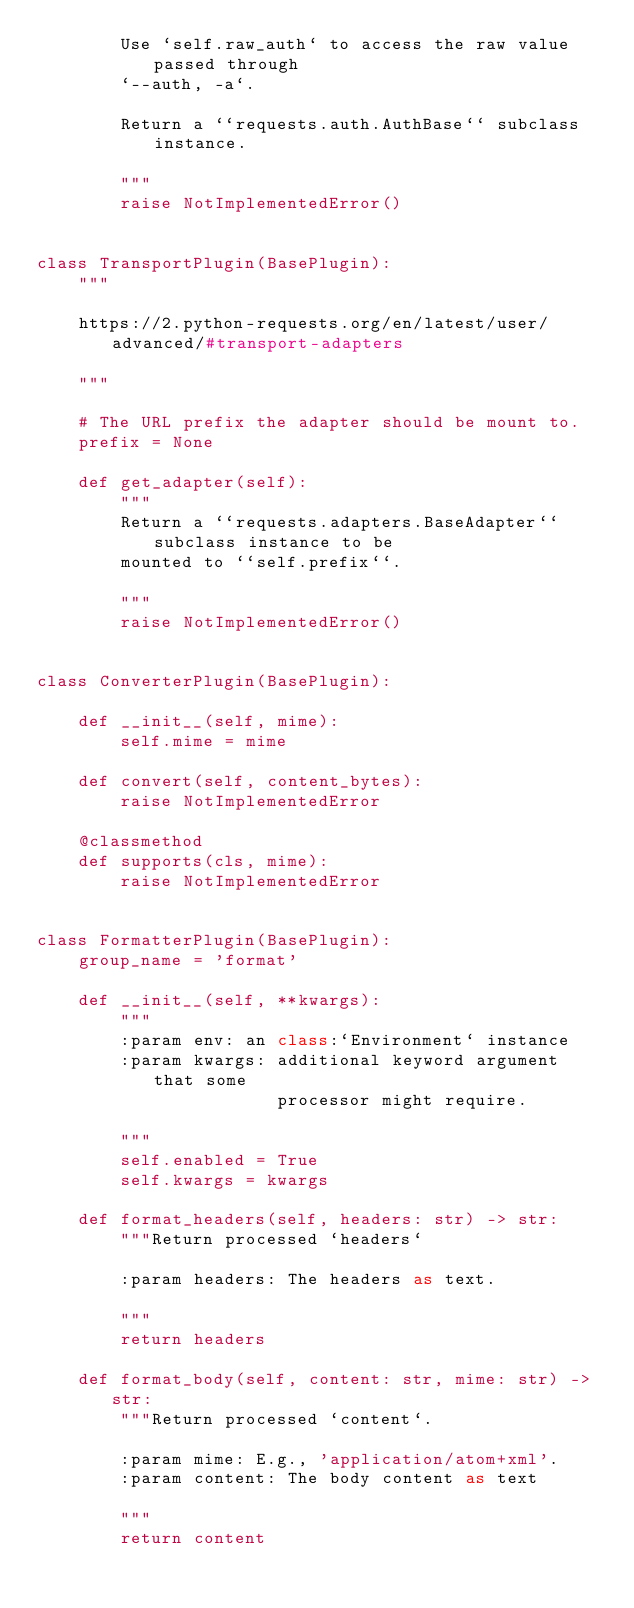<code> <loc_0><loc_0><loc_500><loc_500><_Python_>        Use `self.raw_auth` to access the raw value passed through
        `--auth, -a`.

        Return a ``requests.auth.AuthBase`` subclass instance.

        """
        raise NotImplementedError()


class TransportPlugin(BasePlugin):
    """

    https://2.python-requests.org/en/latest/user/advanced/#transport-adapters

    """

    # The URL prefix the adapter should be mount to.
    prefix = None

    def get_adapter(self):
        """
        Return a ``requests.adapters.BaseAdapter`` subclass instance to be
        mounted to ``self.prefix``.

        """
        raise NotImplementedError()


class ConverterPlugin(BasePlugin):

    def __init__(self, mime):
        self.mime = mime

    def convert(self, content_bytes):
        raise NotImplementedError

    @classmethod
    def supports(cls, mime):
        raise NotImplementedError


class FormatterPlugin(BasePlugin):
    group_name = 'format'

    def __init__(self, **kwargs):
        """
        :param env: an class:`Environment` instance
        :param kwargs: additional keyword argument that some
                       processor might require.

        """
        self.enabled = True
        self.kwargs = kwargs

    def format_headers(self, headers: str) -> str:
        """Return processed `headers`

        :param headers: The headers as text.

        """
        return headers

    def format_body(self, content: str, mime: str) -> str:
        """Return processed `content`.

        :param mime: E.g., 'application/atom+xml'.
        :param content: The body content as text

        """
        return content
</code> 